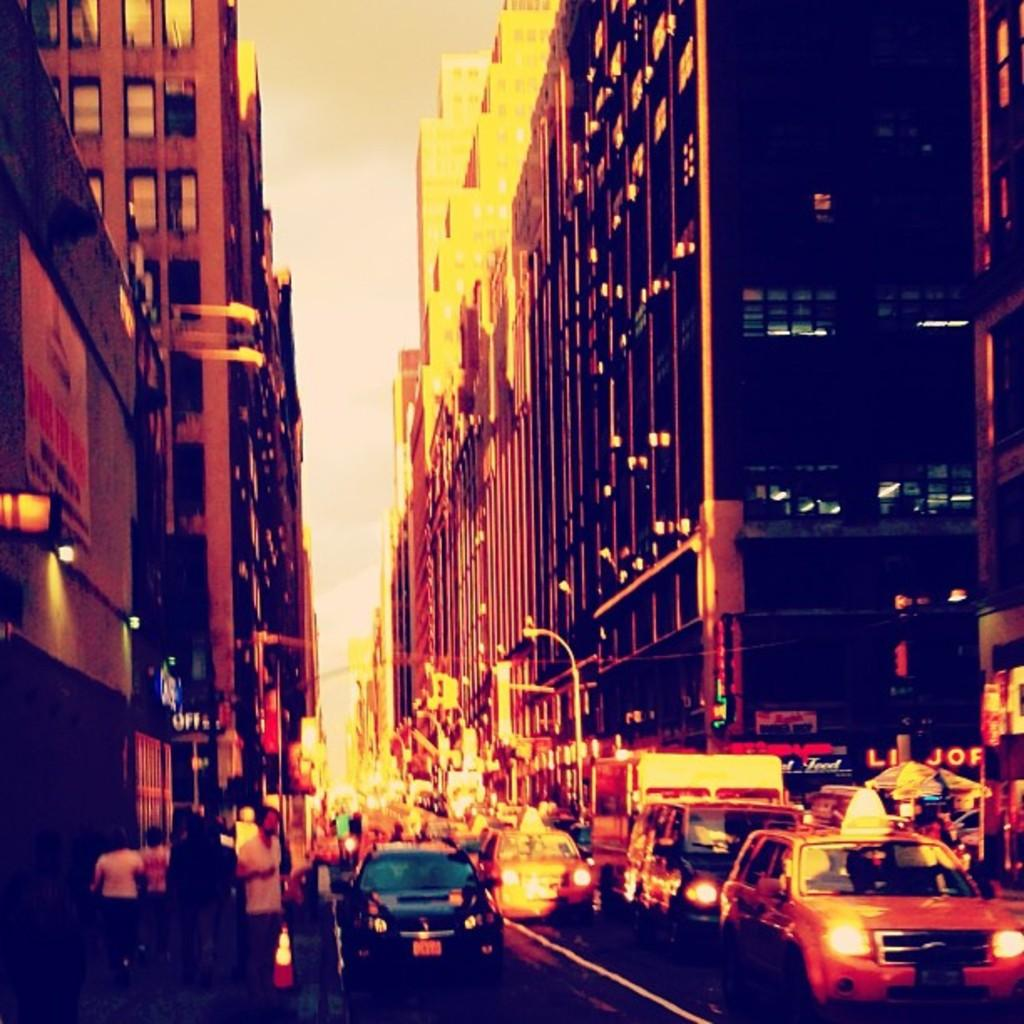What type of structures can be seen in the image? There are buildings in the image. What else can be seen in the image besides buildings? There are poles, vehicles on the road, people, and a traffic cone visible in the image. What is the condition of the sky in the background of the image? The sky is visible in the background of the image. What type of cloud can be seen in the image? There is no cloud present in the image; only buildings, poles, vehicles, people, a traffic cone, and the sky are visible. What type of cast is visible on the person in the image? There is no person with a cast present in the image. What type of pipe is visible in the image? There is no pipe present in the image. 